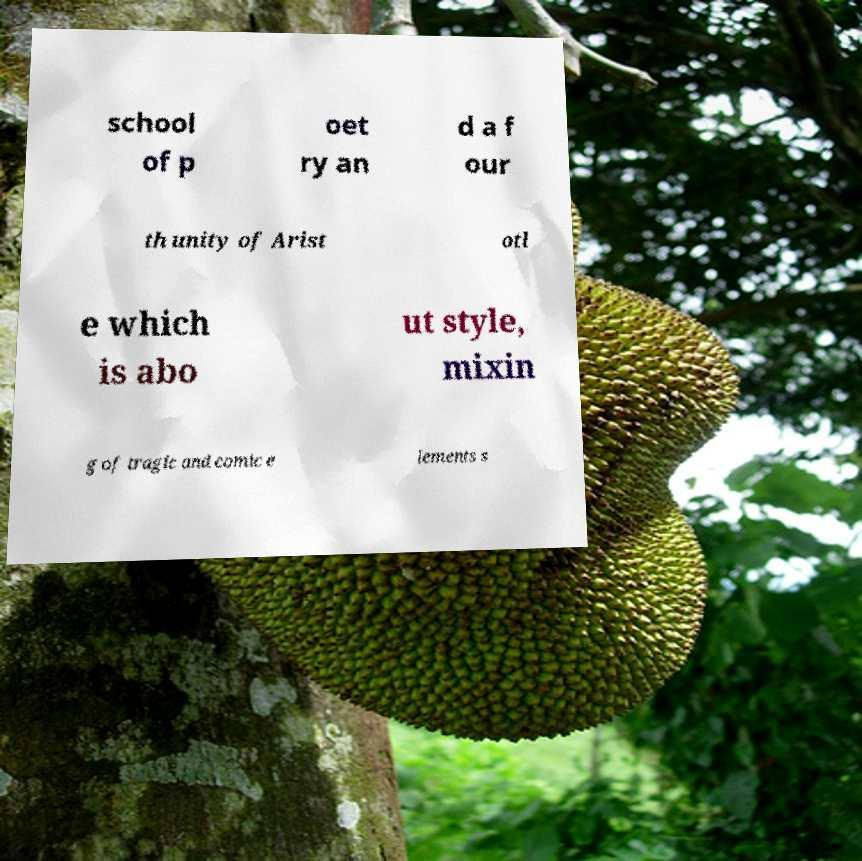Can you accurately transcribe the text from the provided image for me? school of p oet ry an d a f our th unity of Arist otl e which is abo ut style, mixin g of tragic and comic e lements s 